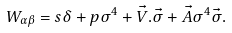<formula> <loc_0><loc_0><loc_500><loc_500>W _ { \alpha \beta } = s \delta + p \sigma ^ { 4 } + \vec { V } . \vec { \sigma } + \vec { A } \sigma ^ { 4 } \vec { \sigma } .</formula> 